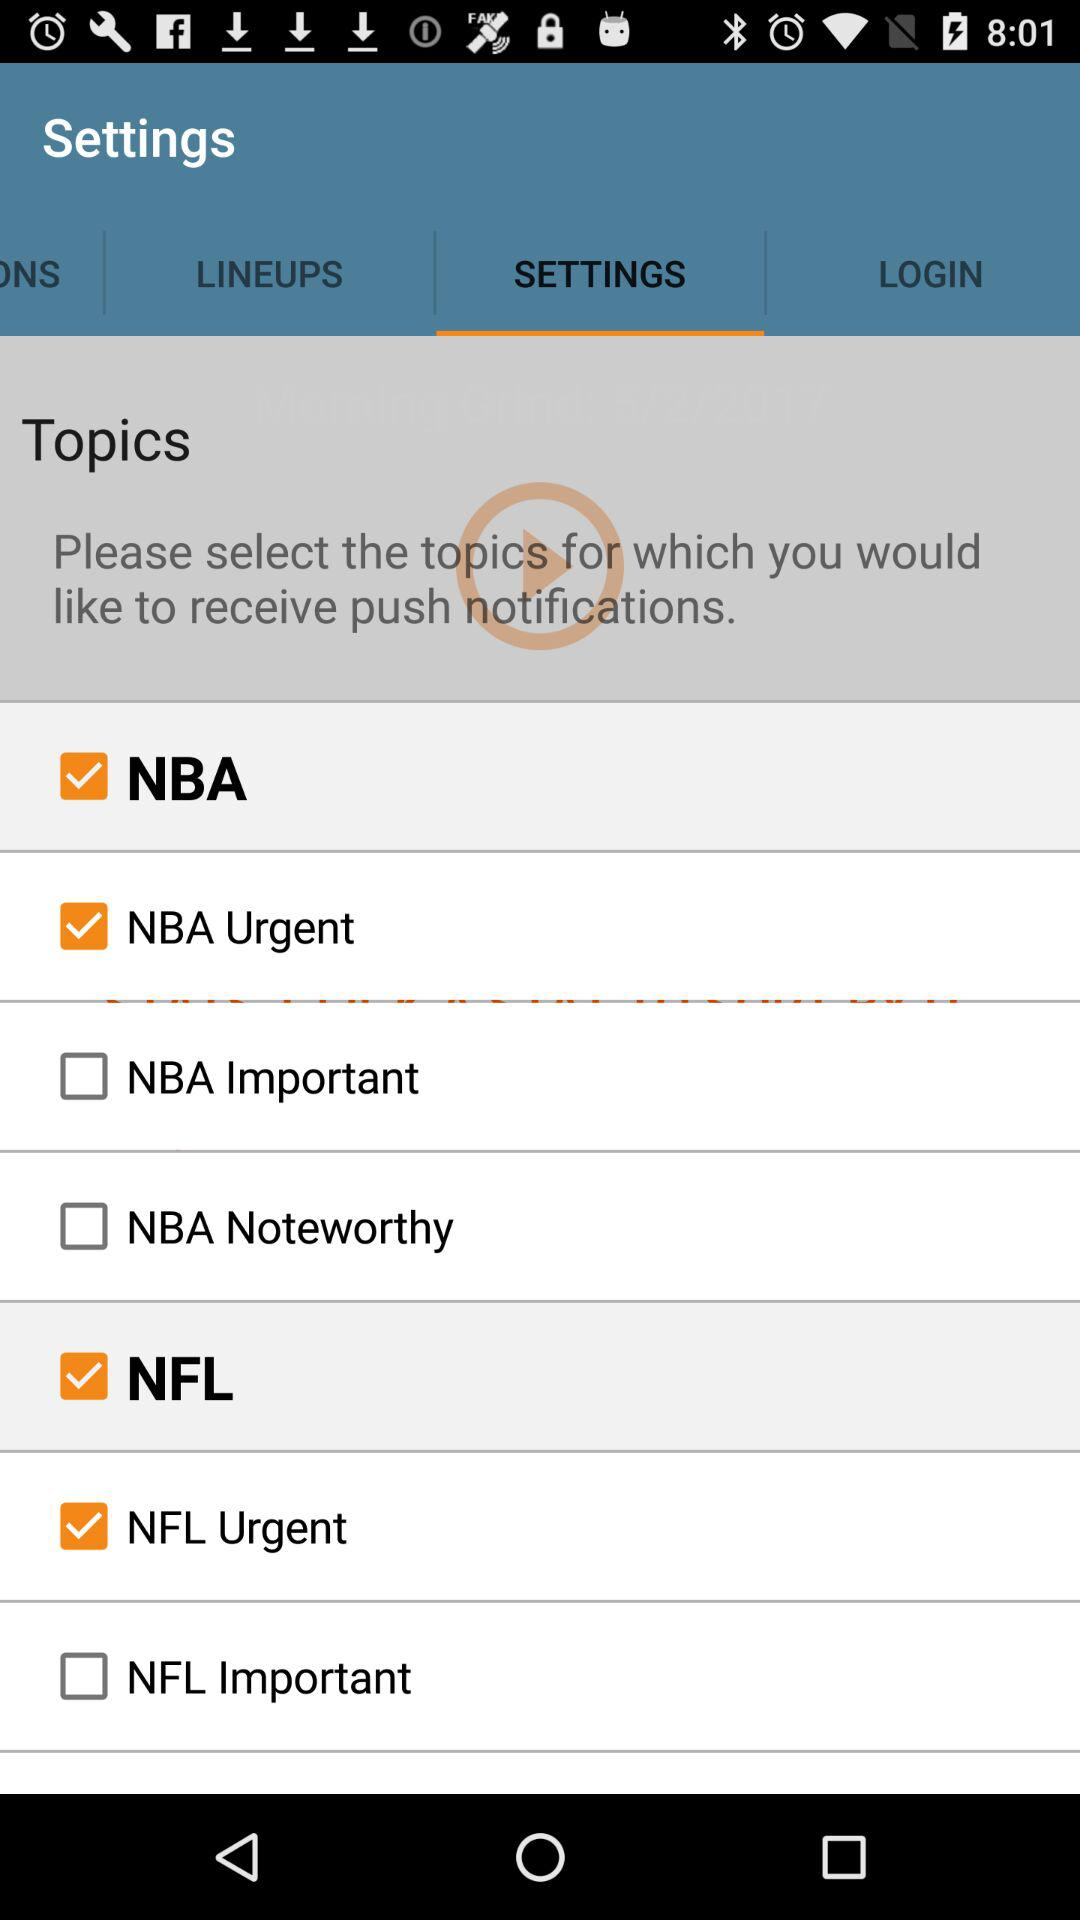What is the status of the "NBA Urgent"? The status is on. 